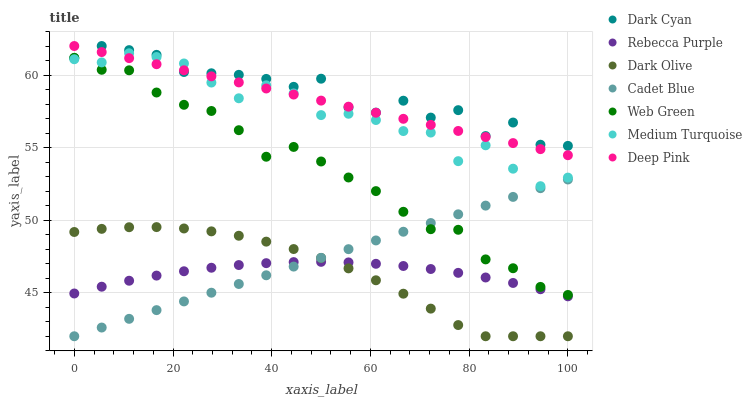Does Rebecca Purple have the minimum area under the curve?
Answer yes or no. Yes. Does Dark Cyan have the maximum area under the curve?
Answer yes or no. Yes. Does Dark Olive have the minimum area under the curve?
Answer yes or no. No. Does Dark Olive have the maximum area under the curve?
Answer yes or no. No. Is Cadet Blue the smoothest?
Answer yes or no. Yes. Is Dark Cyan the roughest?
Answer yes or no. Yes. Is Dark Olive the smoothest?
Answer yes or no. No. Is Dark Olive the roughest?
Answer yes or no. No. Does Cadet Blue have the lowest value?
Answer yes or no. Yes. Does Web Green have the lowest value?
Answer yes or no. No. Does Dark Cyan have the highest value?
Answer yes or no. Yes. Does Dark Olive have the highest value?
Answer yes or no. No. Is Cadet Blue less than Dark Cyan?
Answer yes or no. Yes. Is Dark Cyan greater than Cadet Blue?
Answer yes or no. Yes. Does Web Green intersect Dark Cyan?
Answer yes or no. Yes. Is Web Green less than Dark Cyan?
Answer yes or no. No. Is Web Green greater than Dark Cyan?
Answer yes or no. No. Does Cadet Blue intersect Dark Cyan?
Answer yes or no. No. 